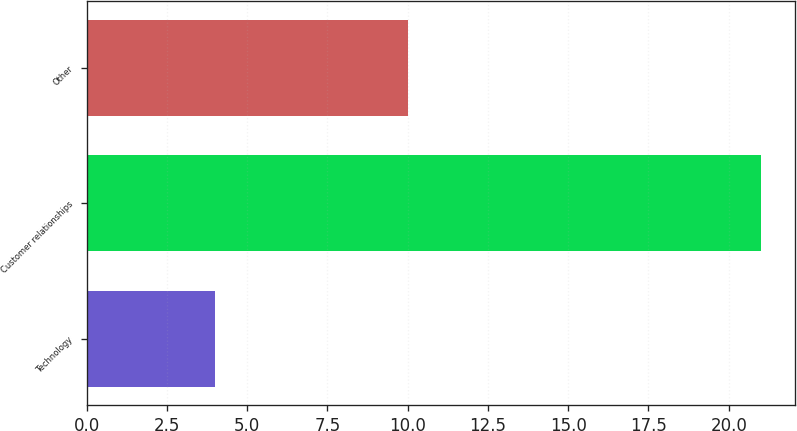Convert chart. <chart><loc_0><loc_0><loc_500><loc_500><bar_chart><fcel>Technology<fcel>Customer relationships<fcel>Other<nl><fcel>4<fcel>21<fcel>10<nl></chart> 